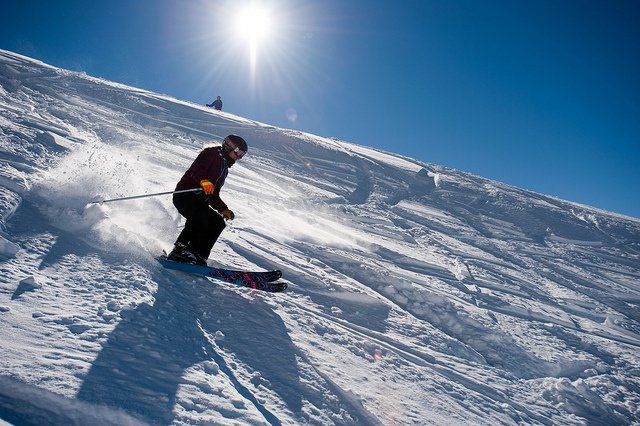Describe the objects in this image and their specific colors. I can see people in navy, black, lightgray, gray, and darkgray tones, skis in navy, black, purple, and gray tones, people in navy, black, and gray tones, and people in navy, darkblue, and gray tones in this image. 